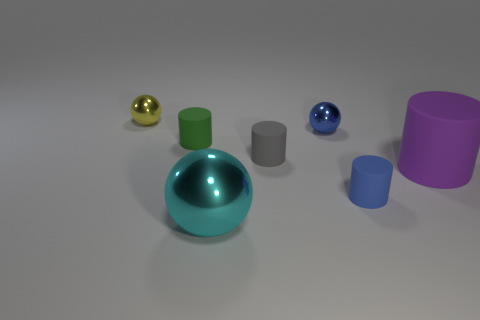How many purple matte objects are there?
Ensure brevity in your answer.  1. Is there a large matte cylinder that has the same color as the large metal thing?
Make the answer very short. No. There is a big thing in front of the rubber cylinder that is to the right of the tiny blue object in front of the small gray matte cylinder; what color is it?
Your response must be concise. Cyan. Is the material of the cyan thing the same as the tiny ball that is on the left side of the cyan metal object?
Ensure brevity in your answer.  Yes. What material is the big cyan sphere?
Your answer should be compact. Metal. What number of other objects are the same material as the purple cylinder?
Keep it short and to the point. 3. What shape is the small object that is behind the tiny gray rubber thing and on the right side of the gray matte thing?
Ensure brevity in your answer.  Sphere. What color is the big object that is made of the same material as the blue cylinder?
Provide a short and direct response. Purple. Are there an equal number of tiny cylinders that are on the left side of the blue rubber cylinder and tiny purple shiny balls?
Offer a very short reply. No. The blue metal thing that is the same size as the yellow metal object is what shape?
Offer a very short reply. Sphere. 